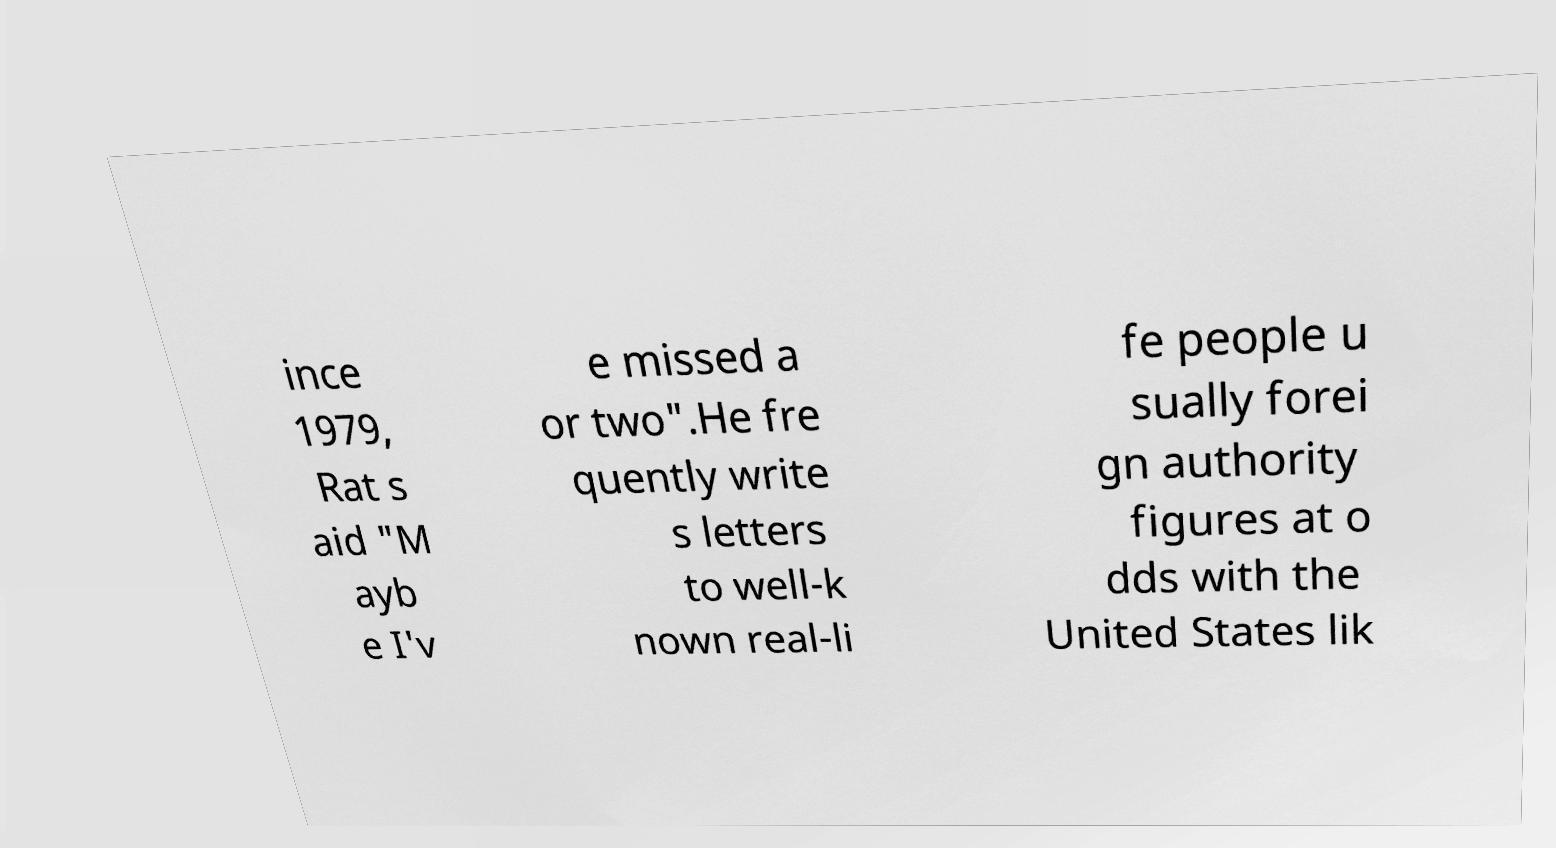What messages or text are displayed in this image? I need them in a readable, typed format. ince 1979, Rat s aid "M ayb e I'v e missed a or two".He fre quently write s letters to well-k nown real-li fe people u sually forei gn authority figures at o dds with the United States lik 